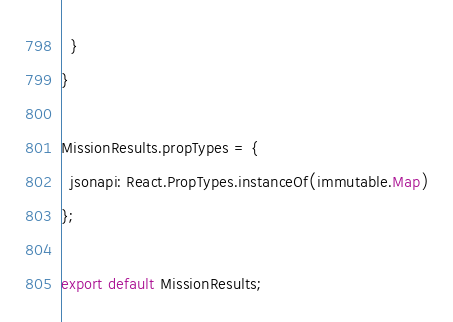<code> <loc_0><loc_0><loc_500><loc_500><_JavaScript_>  }
}

MissionResults.propTypes = {
  jsonapi: React.PropTypes.instanceOf(immutable.Map)
};

export default MissionResults;
</code> 